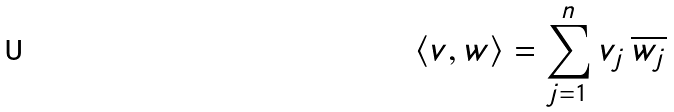Convert formula to latex. <formula><loc_0><loc_0><loc_500><loc_500>\langle v , w \rangle = \sum _ { j = 1 } ^ { n } v _ { j } \, \overline { w _ { j } }</formula> 